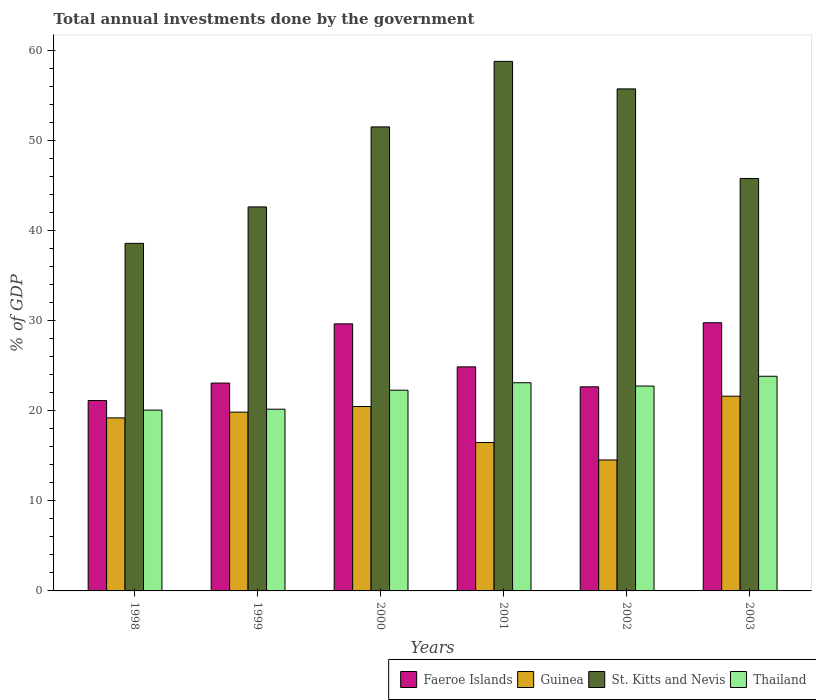Are the number of bars per tick equal to the number of legend labels?
Make the answer very short. Yes. How many bars are there on the 3rd tick from the left?
Offer a terse response. 4. How many bars are there on the 1st tick from the right?
Give a very brief answer. 4. What is the label of the 3rd group of bars from the left?
Offer a very short reply. 2000. In how many cases, is the number of bars for a given year not equal to the number of legend labels?
Give a very brief answer. 0. What is the total annual investments done by the government in St. Kitts and Nevis in 2001?
Keep it short and to the point. 58.79. Across all years, what is the maximum total annual investments done by the government in St. Kitts and Nevis?
Offer a terse response. 58.79. Across all years, what is the minimum total annual investments done by the government in Thailand?
Offer a very short reply. 20.07. In which year was the total annual investments done by the government in St. Kitts and Nevis minimum?
Your response must be concise. 1998. What is the total total annual investments done by the government in Faeroe Islands in the graph?
Your response must be concise. 151.16. What is the difference between the total annual investments done by the government in St. Kitts and Nevis in 1998 and that in 2001?
Your answer should be compact. -20.21. What is the difference between the total annual investments done by the government in Guinea in 1998 and the total annual investments done by the government in St. Kitts and Nevis in 2002?
Your answer should be compact. -36.52. What is the average total annual investments done by the government in Thailand per year?
Keep it short and to the point. 22.04. In the year 1998, what is the difference between the total annual investments done by the government in St. Kitts and Nevis and total annual investments done by the government in Faeroe Islands?
Ensure brevity in your answer.  17.45. In how many years, is the total annual investments done by the government in Thailand greater than 54 %?
Make the answer very short. 0. What is the ratio of the total annual investments done by the government in Faeroe Islands in 2000 to that in 2001?
Ensure brevity in your answer.  1.19. Is the difference between the total annual investments done by the government in St. Kitts and Nevis in 1999 and 2000 greater than the difference between the total annual investments done by the government in Faeroe Islands in 1999 and 2000?
Your answer should be compact. No. What is the difference between the highest and the second highest total annual investments done by the government in St. Kitts and Nevis?
Offer a terse response. 3.06. What is the difference between the highest and the lowest total annual investments done by the government in St. Kitts and Nevis?
Offer a very short reply. 20.21. In how many years, is the total annual investments done by the government in Guinea greater than the average total annual investments done by the government in Guinea taken over all years?
Your answer should be very brief. 4. Is it the case that in every year, the sum of the total annual investments done by the government in Thailand and total annual investments done by the government in Faeroe Islands is greater than the sum of total annual investments done by the government in St. Kitts and Nevis and total annual investments done by the government in Guinea?
Ensure brevity in your answer.  No. What does the 1st bar from the left in 1998 represents?
Your answer should be compact. Faeroe Islands. What does the 3rd bar from the right in 2002 represents?
Give a very brief answer. Guinea. How many bars are there?
Offer a terse response. 24. How many years are there in the graph?
Your answer should be compact. 6. What is the difference between two consecutive major ticks on the Y-axis?
Your answer should be very brief. 10. Does the graph contain any zero values?
Your answer should be very brief. No. How many legend labels are there?
Offer a terse response. 4. What is the title of the graph?
Your answer should be very brief. Total annual investments done by the government. What is the label or title of the Y-axis?
Make the answer very short. % of GDP. What is the % of GDP in Faeroe Islands in 1998?
Give a very brief answer. 21.14. What is the % of GDP in Guinea in 1998?
Provide a short and direct response. 19.21. What is the % of GDP of St. Kitts and Nevis in 1998?
Provide a short and direct response. 38.58. What is the % of GDP in Thailand in 1998?
Your answer should be very brief. 20.07. What is the % of GDP in Faeroe Islands in 1999?
Give a very brief answer. 23.07. What is the % of GDP in Guinea in 1999?
Provide a succinct answer. 19.85. What is the % of GDP in St. Kitts and Nevis in 1999?
Offer a very short reply. 42.63. What is the % of GDP in Thailand in 1999?
Offer a terse response. 20.17. What is the % of GDP of Faeroe Islands in 2000?
Provide a short and direct response. 29.65. What is the % of GDP of Guinea in 2000?
Offer a very short reply. 20.47. What is the % of GDP in St. Kitts and Nevis in 2000?
Make the answer very short. 51.51. What is the % of GDP of Thailand in 2000?
Offer a terse response. 22.28. What is the % of GDP in Faeroe Islands in 2001?
Keep it short and to the point. 24.88. What is the % of GDP of Guinea in 2001?
Make the answer very short. 16.48. What is the % of GDP of St. Kitts and Nevis in 2001?
Ensure brevity in your answer.  58.79. What is the % of GDP of Thailand in 2001?
Ensure brevity in your answer.  23.11. What is the % of GDP of Faeroe Islands in 2002?
Your answer should be very brief. 22.66. What is the % of GDP of Guinea in 2002?
Your answer should be compact. 14.54. What is the % of GDP in St. Kitts and Nevis in 2002?
Provide a succinct answer. 55.73. What is the % of GDP of Thailand in 2002?
Offer a very short reply. 22.74. What is the % of GDP in Faeroe Islands in 2003?
Keep it short and to the point. 29.77. What is the % of GDP of Guinea in 2003?
Offer a very short reply. 21.62. What is the % of GDP in St. Kitts and Nevis in 2003?
Provide a short and direct response. 45.78. What is the % of GDP of Thailand in 2003?
Provide a succinct answer. 23.83. Across all years, what is the maximum % of GDP of Faeroe Islands?
Give a very brief answer. 29.77. Across all years, what is the maximum % of GDP of Guinea?
Provide a short and direct response. 21.62. Across all years, what is the maximum % of GDP of St. Kitts and Nevis?
Make the answer very short. 58.79. Across all years, what is the maximum % of GDP in Thailand?
Keep it short and to the point. 23.83. Across all years, what is the minimum % of GDP of Faeroe Islands?
Your answer should be compact. 21.14. Across all years, what is the minimum % of GDP in Guinea?
Your response must be concise. 14.54. Across all years, what is the minimum % of GDP of St. Kitts and Nevis?
Your answer should be very brief. 38.58. Across all years, what is the minimum % of GDP in Thailand?
Offer a very short reply. 20.07. What is the total % of GDP of Faeroe Islands in the graph?
Ensure brevity in your answer.  151.16. What is the total % of GDP in Guinea in the graph?
Your response must be concise. 112.16. What is the total % of GDP in St. Kitts and Nevis in the graph?
Offer a terse response. 293.02. What is the total % of GDP in Thailand in the graph?
Ensure brevity in your answer.  132.21. What is the difference between the % of GDP in Faeroe Islands in 1998 and that in 1999?
Keep it short and to the point. -1.94. What is the difference between the % of GDP of Guinea in 1998 and that in 1999?
Your response must be concise. -0.64. What is the difference between the % of GDP of St. Kitts and Nevis in 1998 and that in 1999?
Provide a succinct answer. -4.05. What is the difference between the % of GDP in Thailand in 1998 and that in 1999?
Provide a succinct answer. -0.1. What is the difference between the % of GDP in Faeroe Islands in 1998 and that in 2000?
Offer a very short reply. -8.51. What is the difference between the % of GDP of Guinea in 1998 and that in 2000?
Offer a terse response. -1.26. What is the difference between the % of GDP of St. Kitts and Nevis in 1998 and that in 2000?
Your response must be concise. -12.93. What is the difference between the % of GDP in Thailand in 1998 and that in 2000?
Keep it short and to the point. -2.21. What is the difference between the % of GDP in Faeroe Islands in 1998 and that in 2001?
Offer a very short reply. -3.74. What is the difference between the % of GDP in Guinea in 1998 and that in 2001?
Ensure brevity in your answer.  2.73. What is the difference between the % of GDP in St. Kitts and Nevis in 1998 and that in 2001?
Make the answer very short. -20.21. What is the difference between the % of GDP in Thailand in 1998 and that in 2001?
Ensure brevity in your answer.  -3.04. What is the difference between the % of GDP in Faeroe Islands in 1998 and that in 2002?
Provide a succinct answer. -1.52. What is the difference between the % of GDP of Guinea in 1998 and that in 2002?
Keep it short and to the point. 4.67. What is the difference between the % of GDP of St. Kitts and Nevis in 1998 and that in 2002?
Your answer should be compact. -17.15. What is the difference between the % of GDP in Thailand in 1998 and that in 2002?
Give a very brief answer. -2.67. What is the difference between the % of GDP in Faeroe Islands in 1998 and that in 2003?
Provide a succinct answer. -8.63. What is the difference between the % of GDP in Guinea in 1998 and that in 2003?
Offer a terse response. -2.41. What is the difference between the % of GDP of St. Kitts and Nevis in 1998 and that in 2003?
Your answer should be compact. -7.2. What is the difference between the % of GDP of Thailand in 1998 and that in 2003?
Offer a terse response. -3.76. What is the difference between the % of GDP of Faeroe Islands in 1999 and that in 2000?
Provide a succinct answer. -6.58. What is the difference between the % of GDP in Guinea in 1999 and that in 2000?
Keep it short and to the point. -0.63. What is the difference between the % of GDP of St. Kitts and Nevis in 1999 and that in 2000?
Your response must be concise. -8.88. What is the difference between the % of GDP in Thailand in 1999 and that in 2000?
Provide a short and direct response. -2.11. What is the difference between the % of GDP in Faeroe Islands in 1999 and that in 2001?
Keep it short and to the point. -1.8. What is the difference between the % of GDP of Guinea in 1999 and that in 2001?
Ensure brevity in your answer.  3.37. What is the difference between the % of GDP in St. Kitts and Nevis in 1999 and that in 2001?
Your response must be concise. -16.16. What is the difference between the % of GDP of Thailand in 1999 and that in 2001?
Your answer should be very brief. -2.94. What is the difference between the % of GDP of Faeroe Islands in 1999 and that in 2002?
Offer a very short reply. 0.42. What is the difference between the % of GDP in Guinea in 1999 and that in 2002?
Make the answer very short. 5.31. What is the difference between the % of GDP in St. Kitts and Nevis in 1999 and that in 2002?
Your response must be concise. -13.1. What is the difference between the % of GDP in Thailand in 1999 and that in 2002?
Ensure brevity in your answer.  -2.57. What is the difference between the % of GDP of Faeroe Islands in 1999 and that in 2003?
Provide a short and direct response. -6.7. What is the difference between the % of GDP in Guinea in 1999 and that in 2003?
Keep it short and to the point. -1.77. What is the difference between the % of GDP in St. Kitts and Nevis in 1999 and that in 2003?
Keep it short and to the point. -3.15. What is the difference between the % of GDP of Thailand in 1999 and that in 2003?
Your answer should be compact. -3.66. What is the difference between the % of GDP of Faeroe Islands in 2000 and that in 2001?
Provide a succinct answer. 4.77. What is the difference between the % of GDP of Guinea in 2000 and that in 2001?
Ensure brevity in your answer.  4. What is the difference between the % of GDP of St. Kitts and Nevis in 2000 and that in 2001?
Ensure brevity in your answer.  -7.28. What is the difference between the % of GDP in Thailand in 2000 and that in 2001?
Offer a terse response. -0.83. What is the difference between the % of GDP in Faeroe Islands in 2000 and that in 2002?
Ensure brevity in your answer.  6.99. What is the difference between the % of GDP in Guinea in 2000 and that in 2002?
Your answer should be very brief. 5.93. What is the difference between the % of GDP in St. Kitts and Nevis in 2000 and that in 2002?
Provide a succinct answer. -4.22. What is the difference between the % of GDP in Thailand in 2000 and that in 2002?
Keep it short and to the point. -0.46. What is the difference between the % of GDP in Faeroe Islands in 2000 and that in 2003?
Make the answer very short. -0.12. What is the difference between the % of GDP in Guinea in 2000 and that in 2003?
Offer a terse response. -1.14. What is the difference between the % of GDP of St. Kitts and Nevis in 2000 and that in 2003?
Make the answer very short. 5.73. What is the difference between the % of GDP in Thailand in 2000 and that in 2003?
Your answer should be very brief. -1.55. What is the difference between the % of GDP of Faeroe Islands in 2001 and that in 2002?
Your response must be concise. 2.22. What is the difference between the % of GDP of Guinea in 2001 and that in 2002?
Your response must be concise. 1.94. What is the difference between the % of GDP in St. Kitts and Nevis in 2001 and that in 2002?
Make the answer very short. 3.06. What is the difference between the % of GDP in Thailand in 2001 and that in 2002?
Offer a terse response. 0.37. What is the difference between the % of GDP of Faeroe Islands in 2001 and that in 2003?
Ensure brevity in your answer.  -4.9. What is the difference between the % of GDP in Guinea in 2001 and that in 2003?
Ensure brevity in your answer.  -5.14. What is the difference between the % of GDP of St. Kitts and Nevis in 2001 and that in 2003?
Offer a very short reply. 13. What is the difference between the % of GDP of Thailand in 2001 and that in 2003?
Your response must be concise. -0.72. What is the difference between the % of GDP of Faeroe Islands in 2002 and that in 2003?
Give a very brief answer. -7.11. What is the difference between the % of GDP in Guinea in 2002 and that in 2003?
Offer a very short reply. -7.08. What is the difference between the % of GDP of St. Kitts and Nevis in 2002 and that in 2003?
Keep it short and to the point. 9.95. What is the difference between the % of GDP in Thailand in 2002 and that in 2003?
Keep it short and to the point. -1.09. What is the difference between the % of GDP in Faeroe Islands in 1998 and the % of GDP in Guinea in 1999?
Offer a very short reply. 1.29. What is the difference between the % of GDP in Faeroe Islands in 1998 and the % of GDP in St. Kitts and Nevis in 1999?
Give a very brief answer. -21.49. What is the difference between the % of GDP of Faeroe Islands in 1998 and the % of GDP of Thailand in 1999?
Ensure brevity in your answer.  0.96. What is the difference between the % of GDP of Guinea in 1998 and the % of GDP of St. Kitts and Nevis in 1999?
Your answer should be compact. -23.42. What is the difference between the % of GDP of Guinea in 1998 and the % of GDP of Thailand in 1999?
Ensure brevity in your answer.  -0.97. What is the difference between the % of GDP of St. Kitts and Nevis in 1998 and the % of GDP of Thailand in 1999?
Make the answer very short. 18.41. What is the difference between the % of GDP of Faeroe Islands in 1998 and the % of GDP of Guinea in 2000?
Provide a succinct answer. 0.66. What is the difference between the % of GDP in Faeroe Islands in 1998 and the % of GDP in St. Kitts and Nevis in 2000?
Offer a very short reply. -30.37. What is the difference between the % of GDP of Faeroe Islands in 1998 and the % of GDP of Thailand in 2000?
Your answer should be compact. -1.15. What is the difference between the % of GDP of Guinea in 1998 and the % of GDP of St. Kitts and Nevis in 2000?
Your response must be concise. -32.3. What is the difference between the % of GDP in Guinea in 1998 and the % of GDP in Thailand in 2000?
Your answer should be compact. -3.07. What is the difference between the % of GDP in St. Kitts and Nevis in 1998 and the % of GDP in Thailand in 2000?
Make the answer very short. 16.3. What is the difference between the % of GDP of Faeroe Islands in 1998 and the % of GDP of Guinea in 2001?
Make the answer very short. 4.66. What is the difference between the % of GDP of Faeroe Islands in 1998 and the % of GDP of St. Kitts and Nevis in 2001?
Keep it short and to the point. -37.65. What is the difference between the % of GDP of Faeroe Islands in 1998 and the % of GDP of Thailand in 2001?
Provide a short and direct response. -1.98. What is the difference between the % of GDP in Guinea in 1998 and the % of GDP in St. Kitts and Nevis in 2001?
Make the answer very short. -39.58. What is the difference between the % of GDP in Guinea in 1998 and the % of GDP in Thailand in 2001?
Provide a short and direct response. -3.9. What is the difference between the % of GDP in St. Kitts and Nevis in 1998 and the % of GDP in Thailand in 2001?
Your response must be concise. 15.47. What is the difference between the % of GDP in Faeroe Islands in 1998 and the % of GDP in Guinea in 2002?
Your answer should be very brief. 6.6. What is the difference between the % of GDP in Faeroe Islands in 1998 and the % of GDP in St. Kitts and Nevis in 2002?
Your answer should be compact. -34.59. What is the difference between the % of GDP of Faeroe Islands in 1998 and the % of GDP of Thailand in 2002?
Offer a terse response. -1.61. What is the difference between the % of GDP in Guinea in 1998 and the % of GDP in St. Kitts and Nevis in 2002?
Your response must be concise. -36.52. What is the difference between the % of GDP of Guinea in 1998 and the % of GDP of Thailand in 2002?
Provide a short and direct response. -3.54. What is the difference between the % of GDP in St. Kitts and Nevis in 1998 and the % of GDP in Thailand in 2002?
Your response must be concise. 15.84. What is the difference between the % of GDP of Faeroe Islands in 1998 and the % of GDP of Guinea in 2003?
Offer a very short reply. -0.48. What is the difference between the % of GDP of Faeroe Islands in 1998 and the % of GDP of St. Kitts and Nevis in 2003?
Your response must be concise. -24.65. What is the difference between the % of GDP of Faeroe Islands in 1998 and the % of GDP of Thailand in 2003?
Give a very brief answer. -2.69. What is the difference between the % of GDP in Guinea in 1998 and the % of GDP in St. Kitts and Nevis in 2003?
Provide a short and direct response. -26.58. What is the difference between the % of GDP in Guinea in 1998 and the % of GDP in Thailand in 2003?
Ensure brevity in your answer.  -4.62. What is the difference between the % of GDP in St. Kitts and Nevis in 1998 and the % of GDP in Thailand in 2003?
Give a very brief answer. 14.75. What is the difference between the % of GDP of Faeroe Islands in 1999 and the % of GDP of Guinea in 2000?
Keep it short and to the point. 2.6. What is the difference between the % of GDP of Faeroe Islands in 1999 and the % of GDP of St. Kitts and Nevis in 2000?
Offer a terse response. -28.44. What is the difference between the % of GDP in Faeroe Islands in 1999 and the % of GDP in Thailand in 2000?
Keep it short and to the point. 0.79. What is the difference between the % of GDP of Guinea in 1999 and the % of GDP of St. Kitts and Nevis in 2000?
Your answer should be very brief. -31.66. What is the difference between the % of GDP of Guinea in 1999 and the % of GDP of Thailand in 2000?
Provide a short and direct response. -2.44. What is the difference between the % of GDP of St. Kitts and Nevis in 1999 and the % of GDP of Thailand in 2000?
Ensure brevity in your answer.  20.35. What is the difference between the % of GDP in Faeroe Islands in 1999 and the % of GDP in Guinea in 2001?
Provide a short and direct response. 6.6. What is the difference between the % of GDP of Faeroe Islands in 1999 and the % of GDP of St. Kitts and Nevis in 2001?
Offer a very short reply. -35.71. What is the difference between the % of GDP in Faeroe Islands in 1999 and the % of GDP in Thailand in 2001?
Your answer should be very brief. -0.04. What is the difference between the % of GDP of Guinea in 1999 and the % of GDP of St. Kitts and Nevis in 2001?
Make the answer very short. -38.94. What is the difference between the % of GDP in Guinea in 1999 and the % of GDP in Thailand in 2001?
Your answer should be compact. -3.27. What is the difference between the % of GDP in St. Kitts and Nevis in 1999 and the % of GDP in Thailand in 2001?
Provide a succinct answer. 19.52. What is the difference between the % of GDP of Faeroe Islands in 1999 and the % of GDP of Guinea in 2002?
Make the answer very short. 8.54. What is the difference between the % of GDP of Faeroe Islands in 1999 and the % of GDP of St. Kitts and Nevis in 2002?
Provide a succinct answer. -32.66. What is the difference between the % of GDP in Faeroe Islands in 1999 and the % of GDP in Thailand in 2002?
Ensure brevity in your answer.  0.33. What is the difference between the % of GDP of Guinea in 1999 and the % of GDP of St. Kitts and Nevis in 2002?
Offer a terse response. -35.88. What is the difference between the % of GDP of Guinea in 1999 and the % of GDP of Thailand in 2002?
Keep it short and to the point. -2.9. What is the difference between the % of GDP of St. Kitts and Nevis in 1999 and the % of GDP of Thailand in 2002?
Provide a short and direct response. 19.89. What is the difference between the % of GDP in Faeroe Islands in 1999 and the % of GDP in Guinea in 2003?
Your response must be concise. 1.46. What is the difference between the % of GDP in Faeroe Islands in 1999 and the % of GDP in St. Kitts and Nevis in 2003?
Provide a short and direct response. -22.71. What is the difference between the % of GDP of Faeroe Islands in 1999 and the % of GDP of Thailand in 2003?
Provide a short and direct response. -0.76. What is the difference between the % of GDP of Guinea in 1999 and the % of GDP of St. Kitts and Nevis in 2003?
Offer a very short reply. -25.94. What is the difference between the % of GDP of Guinea in 1999 and the % of GDP of Thailand in 2003?
Your answer should be compact. -3.98. What is the difference between the % of GDP of Faeroe Islands in 2000 and the % of GDP of Guinea in 2001?
Provide a succinct answer. 13.17. What is the difference between the % of GDP in Faeroe Islands in 2000 and the % of GDP in St. Kitts and Nevis in 2001?
Provide a short and direct response. -29.14. What is the difference between the % of GDP of Faeroe Islands in 2000 and the % of GDP of Thailand in 2001?
Give a very brief answer. 6.54. What is the difference between the % of GDP of Guinea in 2000 and the % of GDP of St. Kitts and Nevis in 2001?
Make the answer very short. -38.32. What is the difference between the % of GDP in Guinea in 2000 and the % of GDP in Thailand in 2001?
Your answer should be very brief. -2.64. What is the difference between the % of GDP of St. Kitts and Nevis in 2000 and the % of GDP of Thailand in 2001?
Keep it short and to the point. 28.4. What is the difference between the % of GDP of Faeroe Islands in 2000 and the % of GDP of Guinea in 2002?
Ensure brevity in your answer.  15.11. What is the difference between the % of GDP in Faeroe Islands in 2000 and the % of GDP in St. Kitts and Nevis in 2002?
Offer a terse response. -26.08. What is the difference between the % of GDP of Faeroe Islands in 2000 and the % of GDP of Thailand in 2002?
Ensure brevity in your answer.  6.91. What is the difference between the % of GDP of Guinea in 2000 and the % of GDP of St. Kitts and Nevis in 2002?
Your answer should be compact. -35.26. What is the difference between the % of GDP in Guinea in 2000 and the % of GDP in Thailand in 2002?
Provide a succinct answer. -2.27. What is the difference between the % of GDP in St. Kitts and Nevis in 2000 and the % of GDP in Thailand in 2002?
Offer a very short reply. 28.77. What is the difference between the % of GDP of Faeroe Islands in 2000 and the % of GDP of Guinea in 2003?
Provide a short and direct response. 8.03. What is the difference between the % of GDP of Faeroe Islands in 2000 and the % of GDP of St. Kitts and Nevis in 2003?
Ensure brevity in your answer.  -16.13. What is the difference between the % of GDP of Faeroe Islands in 2000 and the % of GDP of Thailand in 2003?
Keep it short and to the point. 5.82. What is the difference between the % of GDP in Guinea in 2000 and the % of GDP in St. Kitts and Nevis in 2003?
Your answer should be compact. -25.31. What is the difference between the % of GDP of Guinea in 2000 and the % of GDP of Thailand in 2003?
Provide a short and direct response. -3.36. What is the difference between the % of GDP of St. Kitts and Nevis in 2000 and the % of GDP of Thailand in 2003?
Make the answer very short. 27.68. What is the difference between the % of GDP of Faeroe Islands in 2001 and the % of GDP of Guinea in 2002?
Keep it short and to the point. 10.34. What is the difference between the % of GDP in Faeroe Islands in 2001 and the % of GDP in St. Kitts and Nevis in 2002?
Your answer should be very brief. -30.85. What is the difference between the % of GDP in Faeroe Islands in 2001 and the % of GDP in Thailand in 2002?
Offer a terse response. 2.13. What is the difference between the % of GDP in Guinea in 2001 and the % of GDP in St. Kitts and Nevis in 2002?
Your answer should be compact. -39.25. What is the difference between the % of GDP of Guinea in 2001 and the % of GDP of Thailand in 2002?
Your answer should be compact. -6.27. What is the difference between the % of GDP of St. Kitts and Nevis in 2001 and the % of GDP of Thailand in 2002?
Your answer should be very brief. 36.04. What is the difference between the % of GDP of Faeroe Islands in 2001 and the % of GDP of Guinea in 2003?
Give a very brief answer. 3.26. What is the difference between the % of GDP of Faeroe Islands in 2001 and the % of GDP of St. Kitts and Nevis in 2003?
Offer a terse response. -20.91. What is the difference between the % of GDP of Faeroe Islands in 2001 and the % of GDP of Thailand in 2003?
Make the answer very short. 1.05. What is the difference between the % of GDP in Guinea in 2001 and the % of GDP in St. Kitts and Nevis in 2003?
Ensure brevity in your answer.  -29.31. What is the difference between the % of GDP of Guinea in 2001 and the % of GDP of Thailand in 2003?
Your response must be concise. -7.35. What is the difference between the % of GDP of St. Kitts and Nevis in 2001 and the % of GDP of Thailand in 2003?
Ensure brevity in your answer.  34.96. What is the difference between the % of GDP in Faeroe Islands in 2002 and the % of GDP in Guinea in 2003?
Your answer should be very brief. 1.04. What is the difference between the % of GDP in Faeroe Islands in 2002 and the % of GDP in St. Kitts and Nevis in 2003?
Offer a very short reply. -23.13. What is the difference between the % of GDP of Faeroe Islands in 2002 and the % of GDP of Thailand in 2003?
Provide a succinct answer. -1.17. What is the difference between the % of GDP of Guinea in 2002 and the % of GDP of St. Kitts and Nevis in 2003?
Keep it short and to the point. -31.25. What is the difference between the % of GDP of Guinea in 2002 and the % of GDP of Thailand in 2003?
Give a very brief answer. -9.29. What is the difference between the % of GDP of St. Kitts and Nevis in 2002 and the % of GDP of Thailand in 2003?
Your answer should be compact. 31.9. What is the average % of GDP in Faeroe Islands per year?
Keep it short and to the point. 25.19. What is the average % of GDP in Guinea per year?
Your response must be concise. 18.69. What is the average % of GDP of St. Kitts and Nevis per year?
Keep it short and to the point. 48.84. What is the average % of GDP of Thailand per year?
Ensure brevity in your answer.  22.04. In the year 1998, what is the difference between the % of GDP of Faeroe Islands and % of GDP of Guinea?
Give a very brief answer. 1.93. In the year 1998, what is the difference between the % of GDP in Faeroe Islands and % of GDP in St. Kitts and Nevis?
Your answer should be very brief. -17.45. In the year 1998, what is the difference between the % of GDP in Faeroe Islands and % of GDP in Thailand?
Make the answer very short. 1.07. In the year 1998, what is the difference between the % of GDP in Guinea and % of GDP in St. Kitts and Nevis?
Provide a succinct answer. -19.37. In the year 1998, what is the difference between the % of GDP of Guinea and % of GDP of Thailand?
Give a very brief answer. -0.86. In the year 1998, what is the difference between the % of GDP in St. Kitts and Nevis and % of GDP in Thailand?
Provide a short and direct response. 18.51. In the year 1999, what is the difference between the % of GDP in Faeroe Islands and % of GDP in Guinea?
Give a very brief answer. 3.23. In the year 1999, what is the difference between the % of GDP in Faeroe Islands and % of GDP in St. Kitts and Nevis?
Keep it short and to the point. -19.56. In the year 1999, what is the difference between the % of GDP of Faeroe Islands and % of GDP of Thailand?
Keep it short and to the point. 2.9. In the year 1999, what is the difference between the % of GDP of Guinea and % of GDP of St. Kitts and Nevis?
Provide a succinct answer. -22.78. In the year 1999, what is the difference between the % of GDP of Guinea and % of GDP of Thailand?
Offer a very short reply. -0.33. In the year 1999, what is the difference between the % of GDP of St. Kitts and Nevis and % of GDP of Thailand?
Keep it short and to the point. 22.46. In the year 2000, what is the difference between the % of GDP of Faeroe Islands and % of GDP of Guinea?
Provide a short and direct response. 9.18. In the year 2000, what is the difference between the % of GDP in Faeroe Islands and % of GDP in St. Kitts and Nevis?
Make the answer very short. -21.86. In the year 2000, what is the difference between the % of GDP of Faeroe Islands and % of GDP of Thailand?
Provide a succinct answer. 7.37. In the year 2000, what is the difference between the % of GDP in Guinea and % of GDP in St. Kitts and Nevis?
Provide a short and direct response. -31.04. In the year 2000, what is the difference between the % of GDP of Guinea and % of GDP of Thailand?
Give a very brief answer. -1.81. In the year 2000, what is the difference between the % of GDP of St. Kitts and Nevis and % of GDP of Thailand?
Your answer should be very brief. 29.23. In the year 2001, what is the difference between the % of GDP of Faeroe Islands and % of GDP of Guinea?
Offer a very short reply. 8.4. In the year 2001, what is the difference between the % of GDP in Faeroe Islands and % of GDP in St. Kitts and Nevis?
Make the answer very short. -33.91. In the year 2001, what is the difference between the % of GDP of Faeroe Islands and % of GDP of Thailand?
Provide a short and direct response. 1.76. In the year 2001, what is the difference between the % of GDP in Guinea and % of GDP in St. Kitts and Nevis?
Keep it short and to the point. -42.31. In the year 2001, what is the difference between the % of GDP in Guinea and % of GDP in Thailand?
Offer a terse response. -6.64. In the year 2001, what is the difference between the % of GDP of St. Kitts and Nevis and % of GDP of Thailand?
Ensure brevity in your answer.  35.68. In the year 2002, what is the difference between the % of GDP of Faeroe Islands and % of GDP of Guinea?
Keep it short and to the point. 8.12. In the year 2002, what is the difference between the % of GDP in Faeroe Islands and % of GDP in St. Kitts and Nevis?
Your response must be concise. -33.07. In the year 2002, what is the difference between the % of GDP in Faeroe Islands and % of GDP in Thailand?
Ensure brevity in your answer.  -0.09. In the year 2002, what is the difference between the % of GDP of Guinea and % of GDP of St. Kitts and Nevis?
Give a very brief answer. -41.19. In the year 2002, what is the difference between the % of GDP in Guinea and % of GDP in Thailand?
Keep it short and to the point. -8.21. In the year 2002, what is the difference between the % of GDP of St. Kitts and Nevis and % of GDP of Thailand?
Ensure brevity in your answer.  32.99. In the year 2003, what is the difference between the % of GDP of Faeroe Islands and % of GDP of Guinea?
Offer a very short reply. 8.15. In the year 2003, what is the difference between the % of GDP of Faeroe Islands and % of GDP of St. Kitts and Nevis?
Ensure brevity in your answer.  -16.01. In the year 2003, what is the difference between the % of GDP in Faeroe Islands and % of GDP in Thailand?
Offer a very short reply. 5.94. In the year 2003, what is the difference between the % of GDP of Guinea and % of GDP of St. Kitts and Nevis?
Ensure brevity in your answer.  -24.17. In the year 2003, what is the difference between the % of GDP of Guinea and % of GDP of Thailand?
Ensure brevity in your answer.  -2.21. In the year 2003, what is the difference between the % of GDP in St. Kitts and Nevis and % of GDP in Thailand?
Provide a succinct answer. 21.95. What is the ratio of the % of GDP of Faeroe Islands in 1998 to that in 1999?
Offer a very short reply. 0.92. What is the ratio of the % of GDP in Guinea in 1998 to that in 1999?
Provide a short and direct response. 0.97. What is the ratio of the % of GDP in St. Kitts and Nevis in 1998 to that in 1999?
Make the answer very short. 0.91. What is the ratio of the % of GDP of Faeroe Islands in 1998 to that in 2000?
Offer a terse response. 0.71. What is the ratio of the % of GDP of Guinea in 1998 to that in 2000?
Make the answer very short. 0.94. What is the ratio of the % of GDP of St. Kitts and Nevis in 1998 to that in 2000?
Your answer should be compact. 0.75. What is the ratio of the % of GDP of Thailand in 1998 to that in 2000?
Provide a succinct answer. 0.9. What is the ratio of the % of GDP of Faeroe Islands in 1998 to that in 2001?
Your answer should be compact. 0.85. What is the ratio of the % of GDP in Guinea in 1998 to that in 2001?
Ensure brevity in your answer.  1.17. What is the ratio of the % of GDP of St. Kitts and Nevis in 1998 to that in 2001?
Your answer should be compact. 0.66. What is the ratio of the % of GDP of Thailand in 1998 to that in 2001?
Keep it short and to the point. 0.87. What is the ratio of the % of GDP in Faeroe Islands in 1998 to that in 2002?
Your answer should be very brief. 0.93. What is the ratio of the % of GDP in Guinea in 1998 to that in 2002?
Your answer should be very brief. 1.32. What is the ratio of the % of GDP in St. Kitts and Nevis in 1998 to that in 2002?
Give a very brief answer. 0.69. What is the ratio of the % of GDP of Thailand in 1998 to that in 2002?
Your answer should be very brief. 0.88. What is the ratio of the % of GDP of Faeroe Islands in 1998 to that in 2003?
Provide a succinct answer. 0.71. What is the ratio of the % of GDP of Guinea in 1998 to that in 2003?
Provide a succinct answer. 0.89. What is the ratio of the % of GDP of St. Kitts and Nevis in 1998 to that in 2003?
Offer a terse response. 0.84. What is the ratio of the % of GDP in Thailand in 1998 to that in 2003?
Provide a short and direct response. 0.84. What is the ratio of the % of GDP of Faeroe Islands in 1999 to that in 2000?
Provide a succinct answer. 0.78. What is the ratio of the % of GDP of Guinea in 1999 to that in 2000?
Keep it short and to the point. 0.97. What is the ratio of the % of GDP in St. Kitts and Nevis in 1999 to that in 2000?
Your response must be concise. 0.83. What is the ratio of the % of GDP of Thailand in 1999 to that in 2000?
Your response must be concise. 0.91. What is the ratio of the % of GDP in Faeroe Islands in 1999 to that in 2001?
Your answer should be very brief. 0.93. What is the ratio of the % of GDP of Guinea in 1999 to that in 2001?
Your answer should be compact. 1.2. What is the ratio of the % of GDP of St. Kitts and Nevis in 1999 to that in 2001?
Offer a very short reply. 0.73. What is the ratio of the % of GDP in Thailand in 1999 to that in 2001?
Your answer should be very brief. 0.87. What is the ratio of the % of GDP in Faeroe Islands in 1999 to that in 2002?
Provide a short and direct response. 1.02. What is the ratio of the % of GDP of Guinea in 1999 to that in 2002?
Give a very brief answer. 1.37. What is the ratio of the % of GDP of St. Kitts and Nevis in 1999 to that in 2002?
Offer a very short reply. 0.76. What is the ratio of the % of GDP of Thailand in 1999 to that in 2002?
Keep it short and to the point. 0.89. What is the ratio of the % of GDP of Faeroe Islands in 1999 to that in 2003?
Make the answer very short. 0.78. What is the ratio of the % of GDP of Guinea in 1999 to that in 2003?
Offer a terse response. 0.92. What is the ratio of the % of GDP of St. Kitts and Nevis in 1999 to that in 2003?
Your response must be concise. 0.93. What is the ratio of the % of GDP of Thailand in 1999 to that in 2003?
Your response must be concise. 0.85. What is the ratio of the % of GDP in Faeroe Islands in 2000 to that in 2001?
Your answer should be very brief. 1.19. What is the ratio of the % of GDP of Guinea in 2000 to that in 2001?
Give a very brief answer. 1.24. What is the ratio of the % of GDP in St. Kitts and Nevis in 2000 to that in 2001?
Give a very brief answer. 0.88. What is the ratio of the % of GDP of Thailand in 2000 to that in 2001?
Your answer should be compact. 0.96. What is the ratio of the % of GDP in Faeroe Islands in 2000 to that in 2002?
Offer a very short reply. 1.31. What is the ratio of the % of GDP of Guinea in 2000 to that in 2002?
Your answer should be compact. 1.41. What is the ratio of the % of GDP of St. Kitts and Nevis in 2000 to that in 2002?
Provide a succinct answer. 0.92. What is the ratio of the % of GDP in Thailand in 2000 to that in 2002?
Your answer should be very brief. 0.98. What is the ratio of the % of GDP in Guinea in 2000 to that in 2003?
Make the answer very short. 0.95. What is the ratio of the % of GDP in St. Kitts and Nevis in 2000 to that in 2003?
Provide a succinct answer. 1.13. What is the ratio of the % of GDP of Thailand in 2000 to that in 2003?
Offer a terse response. 0.94. What is the ratio of the % of GDP in Faeroe Islands in 2001 to that in 2002?
Your answer should be compact. 1.1. What is the ratio of the % of GDP in Guinea in 2001 to that in 2002?
Your answer should be very brief. 1.13. What is the ratio of the % of GDP in St. Kitts and Nevis in 2001 to that in 2002?
Make the answer very short. 1.05. What is the ratio of the % of GDP of Thailand in 2001 to that in 2002?
Provide a succinct answer. 1.02. What is the ratio of the % of GDP of Faeroe Islands in 2001 to that in 2003?
Make the answer very short. 0.84. What is the ratio of the % of GDP of Guinea in 2001 to that in 2003?
Make the answer very short. 0.76. What is the ratio of the % of GDP of St. Kitts and Nevis in 2001 to that in 2003?
Your answer should be very brief. 1.28. What is the ratio of the % of GDP in Thailand in 2001 to that in 2003?
Your answer should be compact. 0.97. What is the ratio of the % of GDP in Faeroe Islands in 2002 to that in 2003?
Your answer should be compact. 0.76. What is the ratio of the % of GDP of Guinea in 2002 to that in 2003?
Keep it short and to the point. 0.67. What is the ratio of the % of GDP in St. Kitts and Nevis in 2002 to that in 2003?
Give a very brief answer. 1.22. What is the ratio of the % of GDP in Thailand in 2002 to that in 2003?
Give a very brief answer. 0.95. What is the difference between the highest and the second highest % of GDP of Faeroe Islands?
Give a very brief answer. 0.12. What is the difference between the highest and the second highest % of GDP in Guinea?
Provide a short and direct response. 1.14. What is the difference between the highest and the second highest % of GDP of St. Kitts and Nevis?
Give a very brief answer. 3.06. What is the difference between the highest and the second highest % of GDP of Thailand?
Your response must be concise. 0.72. What is the difference between the highest and the lowest % of GDP in Faeroe Islands?
Provide a succinct answer. 8.63. What is the difference between the highest and the lowest % of GDP in Guinea?
Offer a terse response. 7.08. What is the difference between the highest and the lowest % of GDP in St. Kitts and Nevis?
Your answer should be compact. 20.21. What is the difference between the highest and the lowest % of GDP in Thailand?
Your answer should be compact. 3.76. 